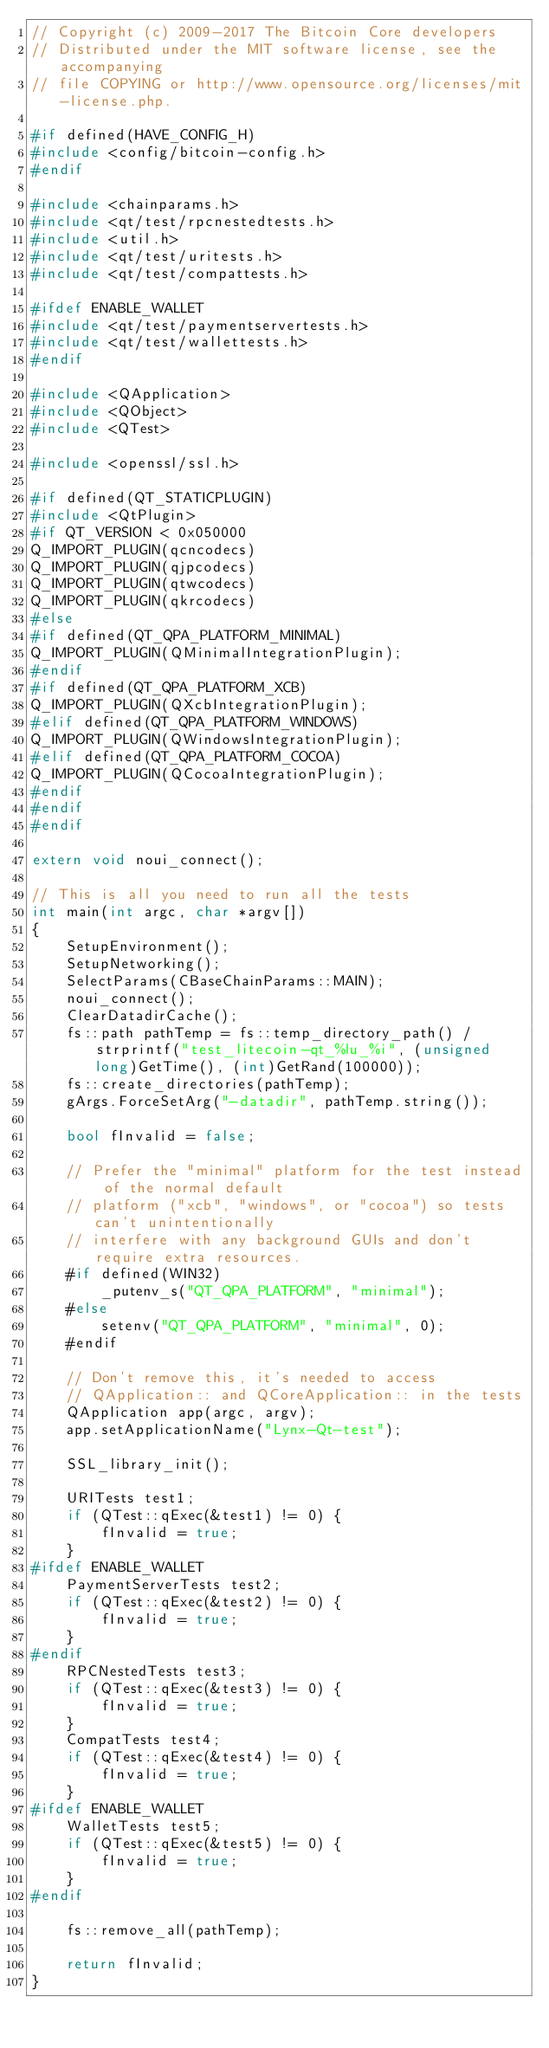Convert code to text. <code><loc_0><loc_0><loc_500><loc_500><_C++_>// Copyright (c) 2009-2017 The Bitcoin Core developers
// Distributed under the MIT software license, see the accompanying
// file COPYING or http://www.opensource.org/licenses/mit-license.php.

#if defined(HAVE_CONFIG_H)
#include <config/bitcoin-config.h>
#endif

#include <chainparams.h>
#include <qt/test/rpcnestedtests.h>
#include <util.h>
#include <qt/test/uritests.h>
#include <qt/test/compattests.h>

#ifdef ENABLE_WALLET
#include <qt/test/paymentservertests.h>
#include <qt/test/wallettests.h>
#endif

#include <QApplication>
#include <QObject>
#include <QTest>

#include <openssl/ssl.h>

#if defined(QT_STATICPLUGIN)
#include <QtPlugin>
#if QT_VERSION < 0x050000
Q_IMPORT_PLUGIN(qcncodecs)
Q_IMPORT_PLUGIN(qjpcodecs)
Q_IMPORT_PLUGIN(qtwcodecs)
Q_IMPORT_PLUGIN(qkrcodecs)
#else
#if defined(QT_QPA_PLATFORM_MINIMAL)
Q_IMPORT_PLUGIN(QMinimalIntegrationPlugin);
#endif
#if defined(QT_QPA_PLATFORM_XCB)
Q_IMPORT_PLUGIN(QXcbIntegrationPlugin);
#elif defined(QT_QPA_PLATFORM_WINDOWS)
Q_IMPORT_PLUGIN(QWindowsIntegrationPlugin);
#elif defined(QT_QPA_PLATFORM_COCOA)
Q_IMPORT_PLUGIN(QCocoaIntegrationPlugin);
#endif
#endif
#endif

extern void noui_connect();

// This is all you need to run all the tests
int main(int argc, char *argv[])
{
    SetupEnvironment();
    SetupNetworking();
    SelectParams(CBaseChainParams::MAIN);
    noui_connect();
    ClearDatadirCache();
    fs::path pathTemp = fs::temp_directory_path() / strprintf("test_litecoin-qt_%lu_%i", (unsigned long)GetTime(), (int)GetRand(100000));
    fs::create_directories(pathTemp);
    gArgs.ForceSetArg("-datadir", pathTemp.string());

    bool fInvalid = false;

    // Prefer the "minimal" platform for the test instead of the normal default
    // platform ("xcb", "windows", or "cocoa") so tests can't unintentionally
    // interfere with any background GUIs and don't require extra resources.
    #if defined(WIN32)
        _putenv_s("QT_QPA_PLATFORM", "minimal");
    #else
        setenv("QT_QPA_PLATFORM", "minimal", 0);
    #endif

    // Don't remove this, it's needed to access
    // QApplication:: and QCoreApplication:: in the tests
    QApplication app(argc, argv);
    app.setApplicationName("Lynx-Qt-test");

    SSL_library_init();

    URITests test1;
    if (QTest::qExec(&test1) != 0) {
        fInvalid = true;
    }
#ifdef ENABLE_WALLET
    PaymentServerTests test2;
    if (QTest::qExec(&test2) != 0) {
        fInvalid = true;
    }
#endif
    RPCNestedTests test3;
    if (QTest::qExec(&test3) != 0) {
        fInvalid = true;
    }
    CompatTests test4;
    if (QTest::qExec(&test4) != 0) {
        fInvalid = true;
    }
#ifdef ENABLE_WALLET
    WalletTests test5;
    if (QTest::qExec(&test5) != 0) {
        fInvalid = true;
    }
#endif

    fs::remove_all(pathTemp);

    return fInvalid;
}
</code> 